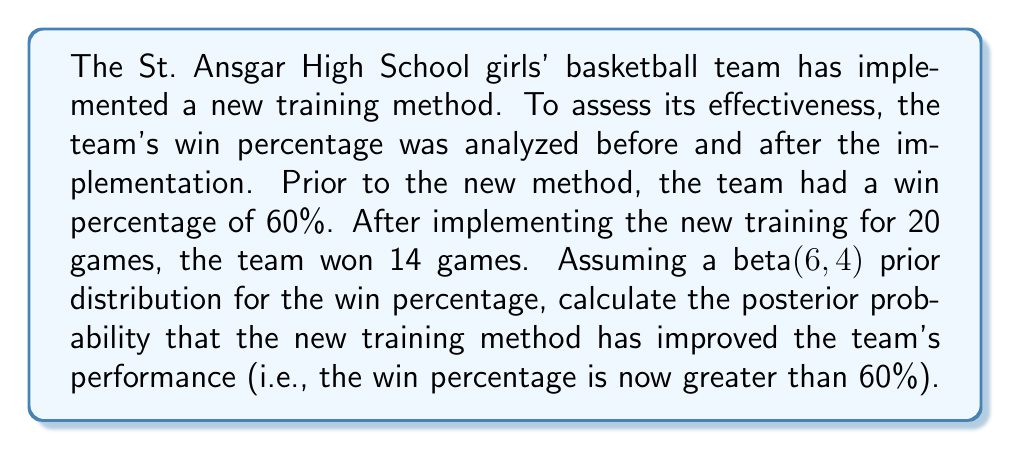Show me your answer to this math problem. Let's approach this problem using Bayesian hypothesis testing:

1) Define the hypothesis:
   $H_0$: Win percentage $\leq 60\%$
   $H_1$: Win percentage $> 60\%$

2) Prior distribution:
   We are given a beta(6,4) prior distribution. This means:
   $\alpha_{prior} = 6$
   $\beta_{prior} = 4$

3) Likelihood:
   In 20 games, the team won 14 games. This follows a binomial distribution:
   $x = 14$ (successes)
   $n = 20$ (trials)

4) Posterior distribution:
   The posterior distribution is also a beta distribution with parameters:
   $\alpha_{posterior} = \alpha_{prior} + x = 6 + 14 = 20$
   $\beta_{posterior} = \beta_{prior} + (n-x) = 4 + (20-14) = 10$

   So, the posterior distribution is beta(20,10).

5) Calculate the probability that the win percentage is greater than 60%:
   We need to find $P(\theta > 0.6)$ where $\theta$ follows a beta(20,10) distribution.

   This can be calculated using the cumulative beta distribution function:

   $P(\theta > 0.6) = 1 - P(\theta \leq 0.6) = 1 - I_{0.6}(20,10)$

   Where $I_{0.6}(20,10)$ is the regularized incomplete beta function.

6) Using a statistical calculator or software, we can compute:
   $I_{0.6}(20,10) \approx 0.1286$

7) Therefore:
   $P(\theta > 0.6) = 1 - 0.1286 \approx 0.8714$
Answer: The posterior probability that the new training method has improved the team's performance (win percentage is now greater than 60%) is approximately 0.8714 or 87.14%. 